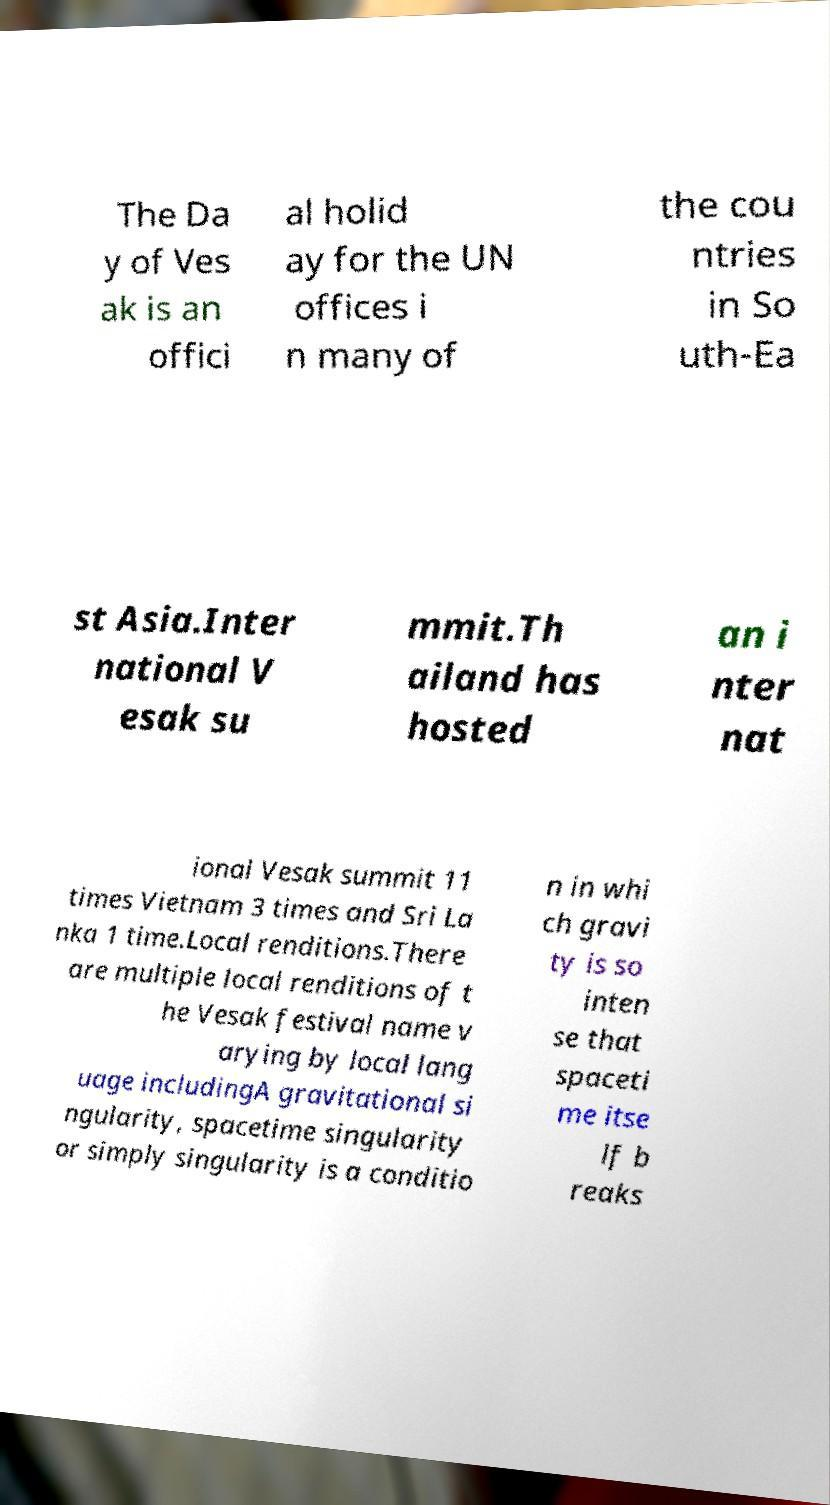Can you accurately transcribe the text from the provided image for me? The Da y of Ves ak is an offici al holid ay for the UN offices i n many of the cou ntries in So uth-Ea st Asia.Inter national V esak su mmit.Th ailand has hosted an i nter nat ional Vesak summit 11 times Vietnam 3 times and Sri La nka 1 time.Local renditions.There are multiple local renditions of t he Vesak festival name v arying by local lang uage includingA gravitational si ngularity, spacetime singularity or simply singularity is a conditio n in whi ch gravi ty is so inten se that spaceti me itse lf b reaks 